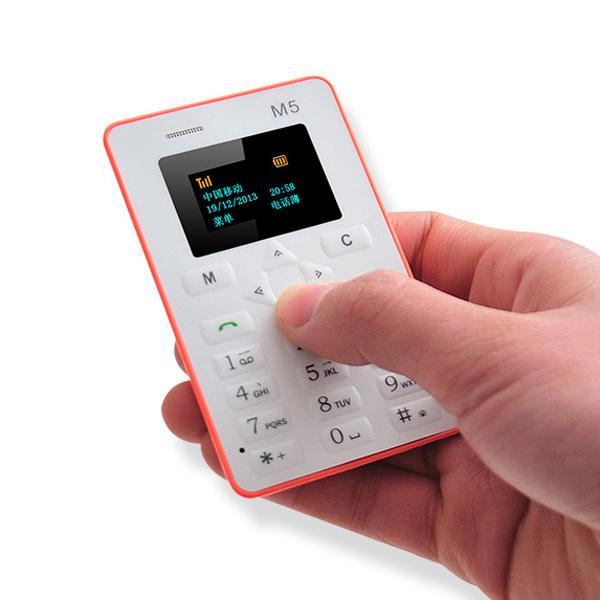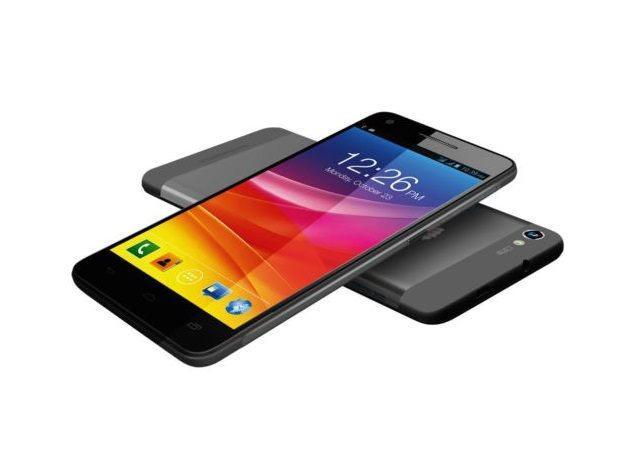The first image is the image on the left, the second image is the image on the right. Analyze the images presented: Is the assertion "A person is holding a white device in the image on the left." valid? Answer yes or no. Yes. The first image is the image on the left, the second image is the image on the right. For the images displayed, is the sentence "A person is holding something in the right image." factually correct? Answer yes or no. No. 